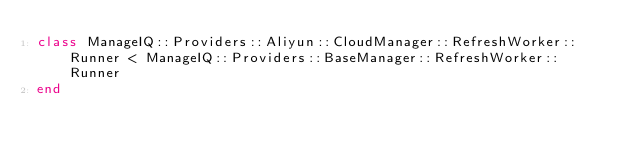Convert code to text. <code><loc_0><loc_0><loc_500><loc_500><_Ruby_>class ManageIQ::Providers::Aliyun::CloudManager::RefreshWorker::Runner < ManageIQ::Providers::BaseManager::RefreshWorker::Runner
end
</code> 